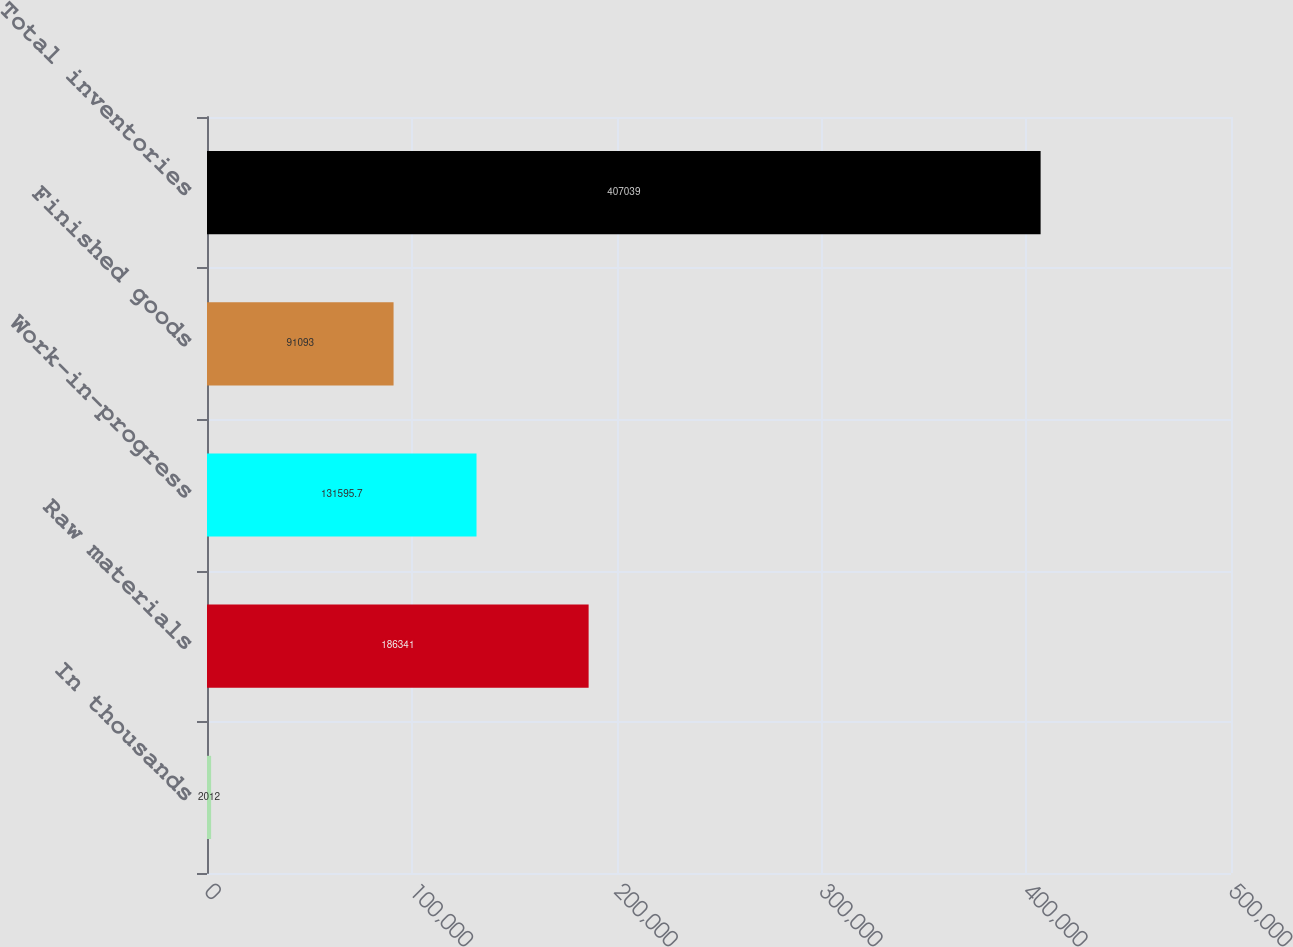<chart> <loc_0><loc_0><loc_500><loc_500><bar_chart><fcel>In thousands<fcel>Raw materials<fcel>Work-in-progress<fcel>Finished goods<fcel>Total inventories<nl><fcel>2012<fcel>186341<fcel>131596<fcel>91093<fcel>407039<nl></chart> 